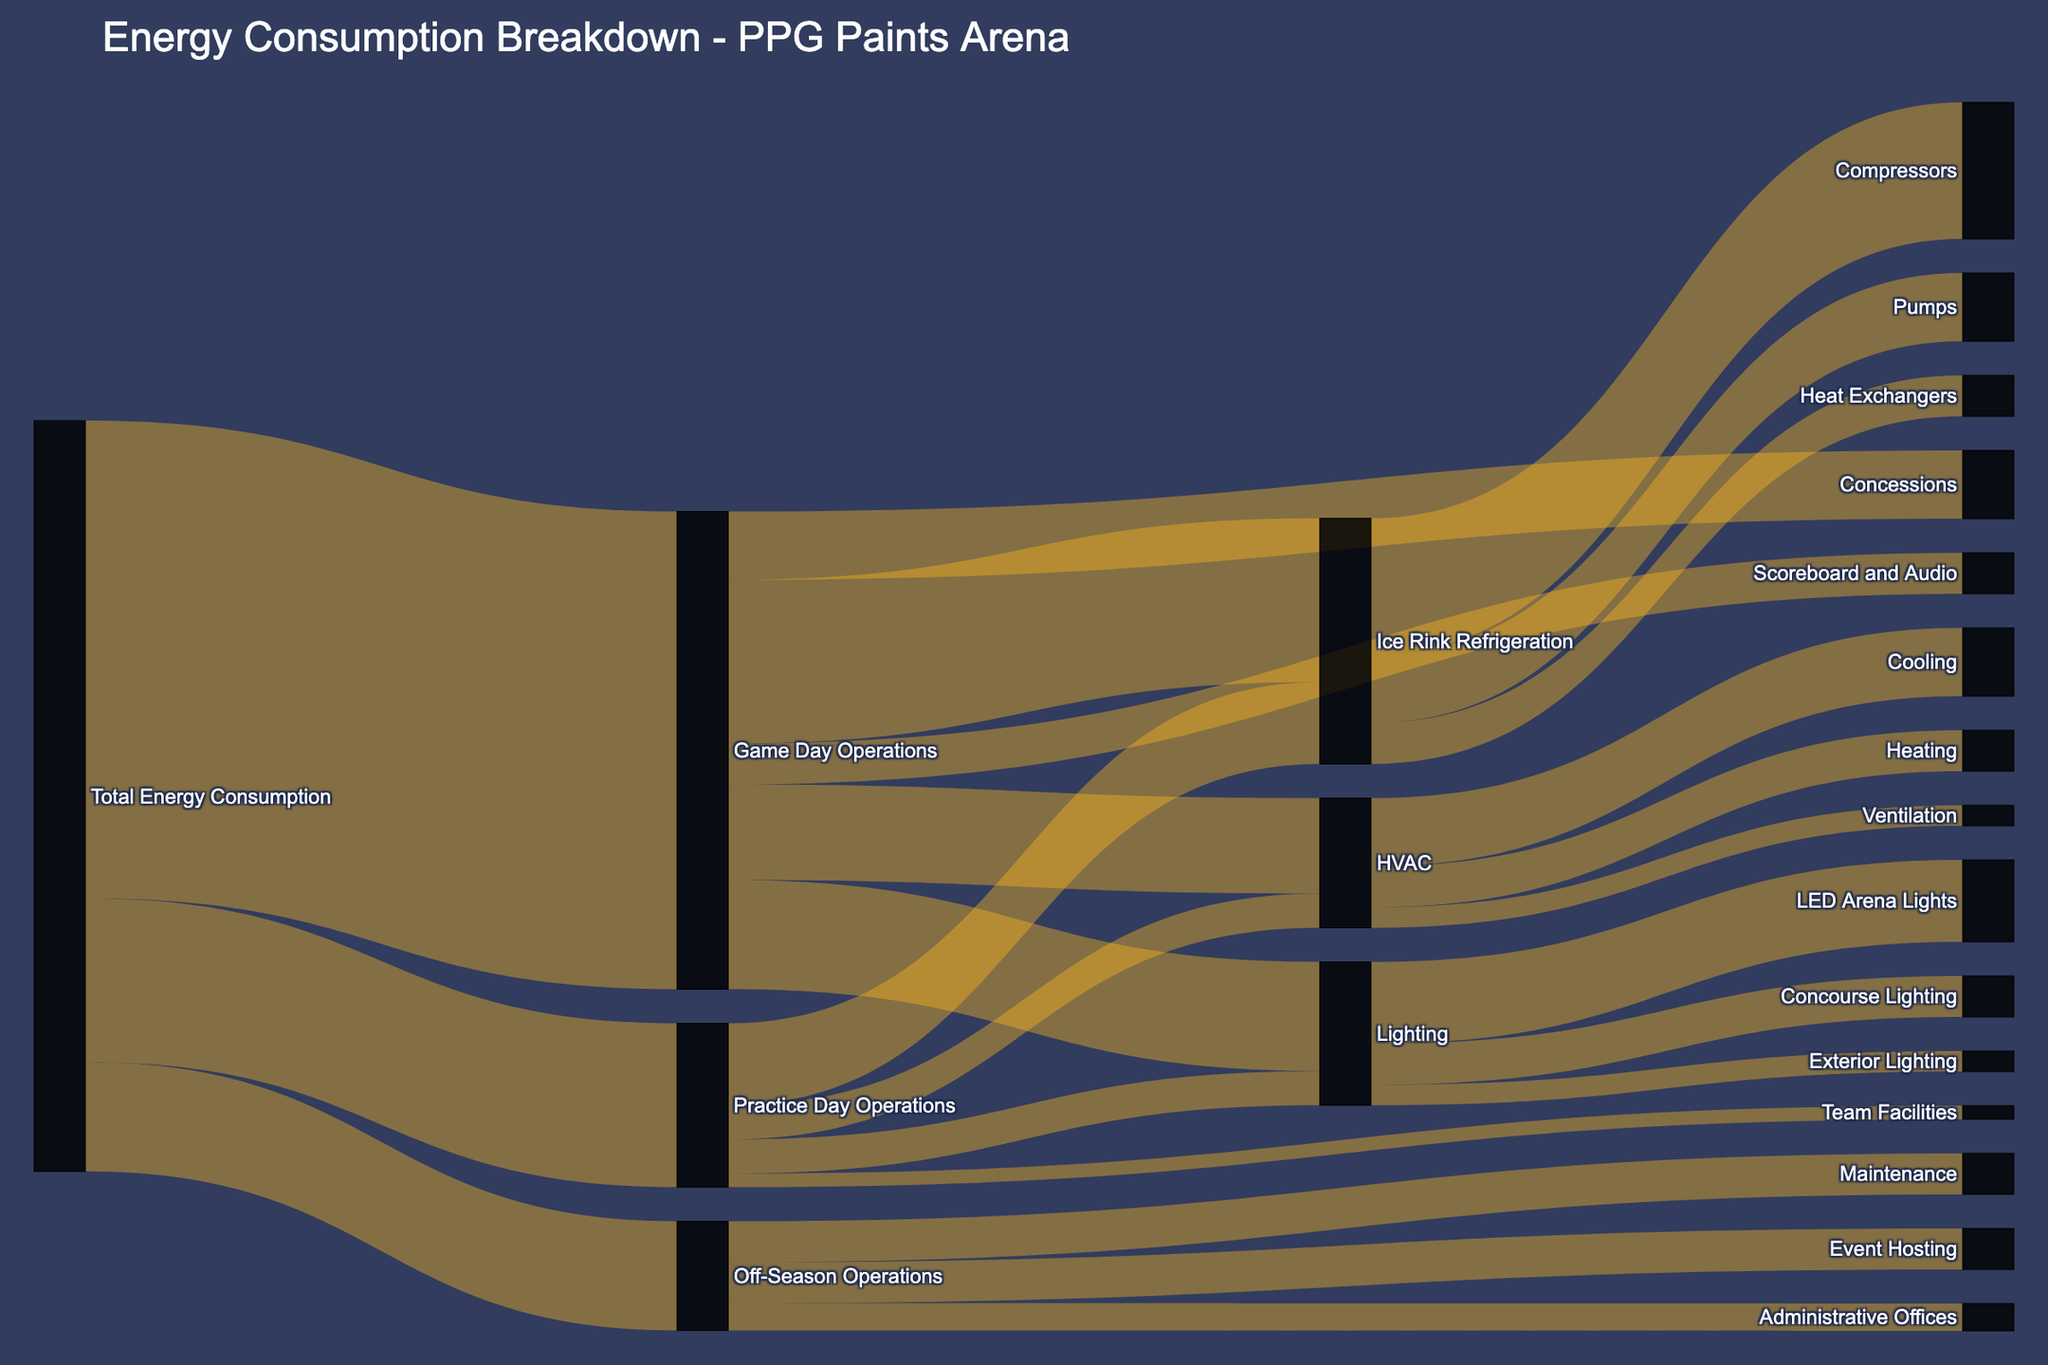How much total energy is consumed by PPG Paints Arena during game days? The total energy consumption for Game Day Operations is shown on the Sankey diagram as 3500 units.
Answer: 3500 units Which activity has the highest energy consumption within Game Day Operations? The Ice Rink Refrigeration consumes 1200 units out of the various components of Game Day Operations, which is the highest among all listed activities.
Answer: Ice Rink Refrigeration How does energy consumption for Ice Rink Refrigeration on practice days compare to game days? Ice Rink Refrigeration consumes 1200 units on game days and 600 units on practice days. Therefore, game days consume 600 more units than practice days.
Answer: 600 more units on game days What proportion of Total Energy Consumption is used for Off-Season Operations? Off-Season Operations consume 800 units out of the total energy consumption of 5500 units (3500 for game days, 1200 for practice days, and 800 for off-season), so the proportion is 800/5500. This simplifies to approximately 14.5%.
Answer: Approximately 14.5% What is the total energy consumption for Lighting during game days and practice days? For game days, Lighting consumes 800 units. For practice days, Lighting consumes 250 units. The total for both is 800 + 250 = 1050 units.
Answer: 1050 units How does energy consumption for Maintenance in the offseason compare to Administrative Offices? Maintenance consumes 300 units during the off-season, while Administrative Offices consume 200 units. Therefore, Maintenance consumes 100 more units than Administrative Offices.
Answer: 100 more units What is the total energy consumption for all HVAC-related activities on game days? HVAC-related activities on game days include Cooling (500 units), Heating (300 units), and Ventilation (150 units). The total is 500 + 300 + 150 = 950 units.
Answer: 950 units What percentage of the Ice Rink Refrigeration energy consumption comes from compressors? The Ice Rink Refrigeration consumes 1800 units in total (1000 for Compressors, 500 for Pumps, and 300 for Heat Exchangers). The percentage attributed to Compressors is (1000/1800) * 100 ≈ 55.56%.
Answer: Approximately 55.56% How much more energy is consumed by Ice Rink Refrigeration compared to Lighting on game days? Ice Rink Refrigeration consumes 1200 units and Lighting consumes 800 units on game days. The difference is 1200 - 800 = 400 units.
Answer: 400 units Which has a higher energy consumption, event hosting in the off-season or scoreboard and audio on game days? Event Hosting in the off-season consumes 300 units, whereas Scoreboard and Audio on game days consume the same amount of 300 units. Thus, they have equal energy consumption.
Answer: They are equal 